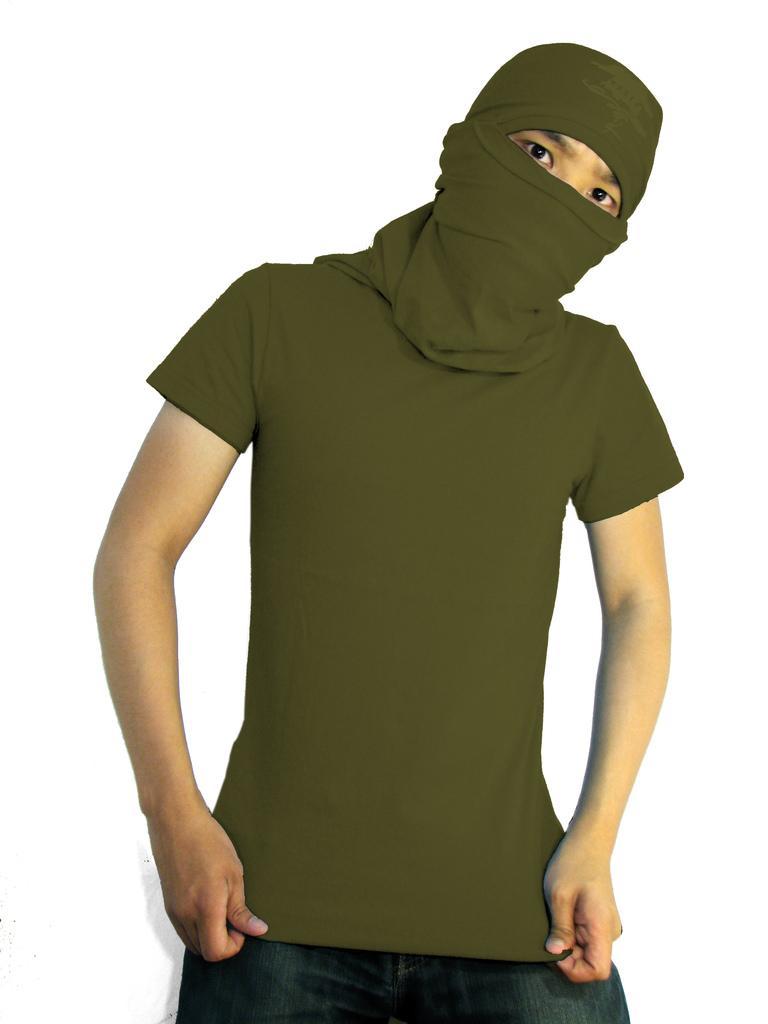Please provide a concise description of this image. In this picture, we can see a person with head-wear, and we can see the white background. 